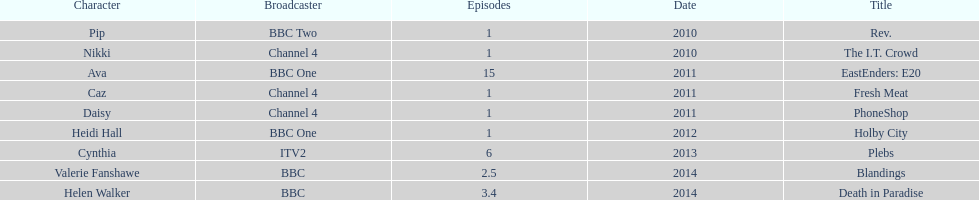Parse the table in full. {'header': ['Character', 'Broadcaster', 'Episodes', 'Date', 'Title'], 'rows': [['Pip', 'BBC Two', '1', '2010', 'Rev.'], ['Nikki', 'Channel 4', '1', '2010', 'The I.T. Crowd'], ['Ava', 'BBC One', '15', '2011', 'EastEnders: E20'], ['Caz', 'Channel 4', '1', '2011', 'Fresh Meat'], ['Daisy', 'Channel 4', '1', '2011', 'PhoneShop'], ['Heidi Hall', 'BBC One', '1', '2012', 'Holby City'], ['Cynthia', 'ITV2', '6', '2013', 'Plebs'], ['Valerie Fanshawe', 'BBC', '2.5', '2014', 'Blandings'], ['Helen Walker', 'BBC', '3.4', '2014', 'Death in Paradise']]} How many titles only had one episode? 5. 